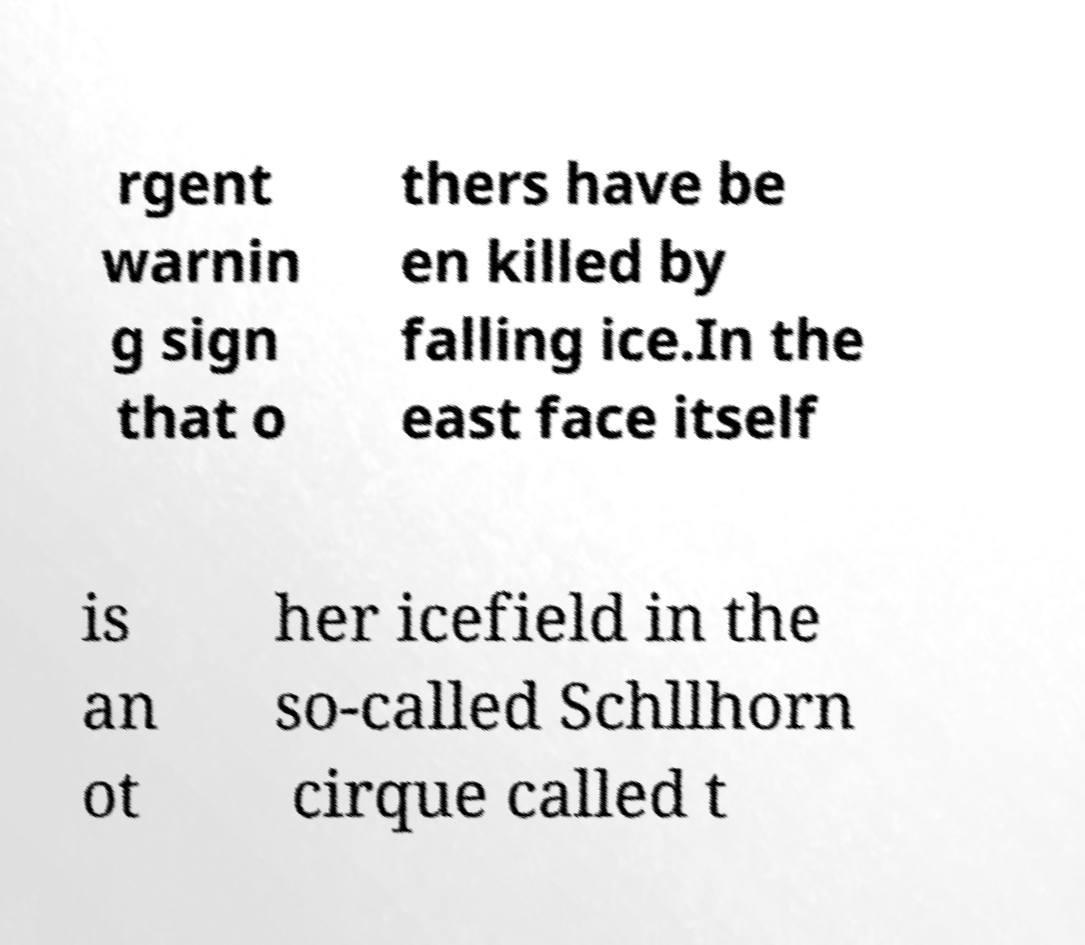Can you accurately transcribe the text from the provided image for me? rgent warnin g sign that o thers have be en killed by falling ice.In the east face itself is an ot her icefield in the so-called Schllhorn cirque called t 